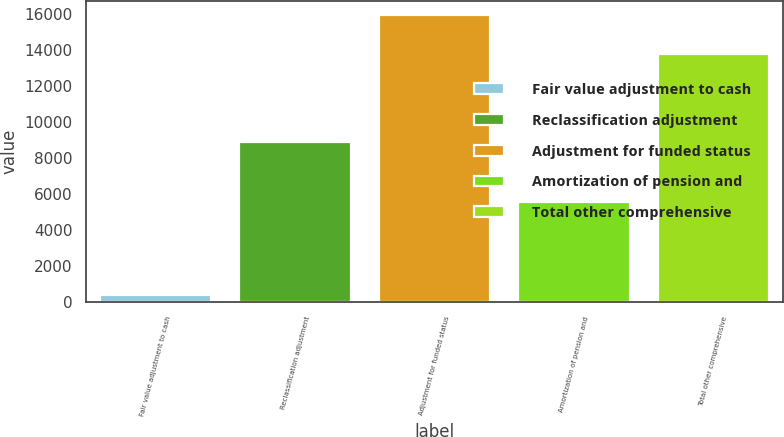Convert chart to OTSL. <chart><loc_0><loc_0><loc_500><loc_500><bar_chart><fcel>Fair value adjustment to cash<fcel>Reclassification adjustment<fcel>Adjustment for funded status<fcel>Amortization of pension and<fcel>Total other comprehensive<nl><fcel>401<fcel>8910<fcel>15960<fcel>5593.8<fcel>13772<nl></chart> 